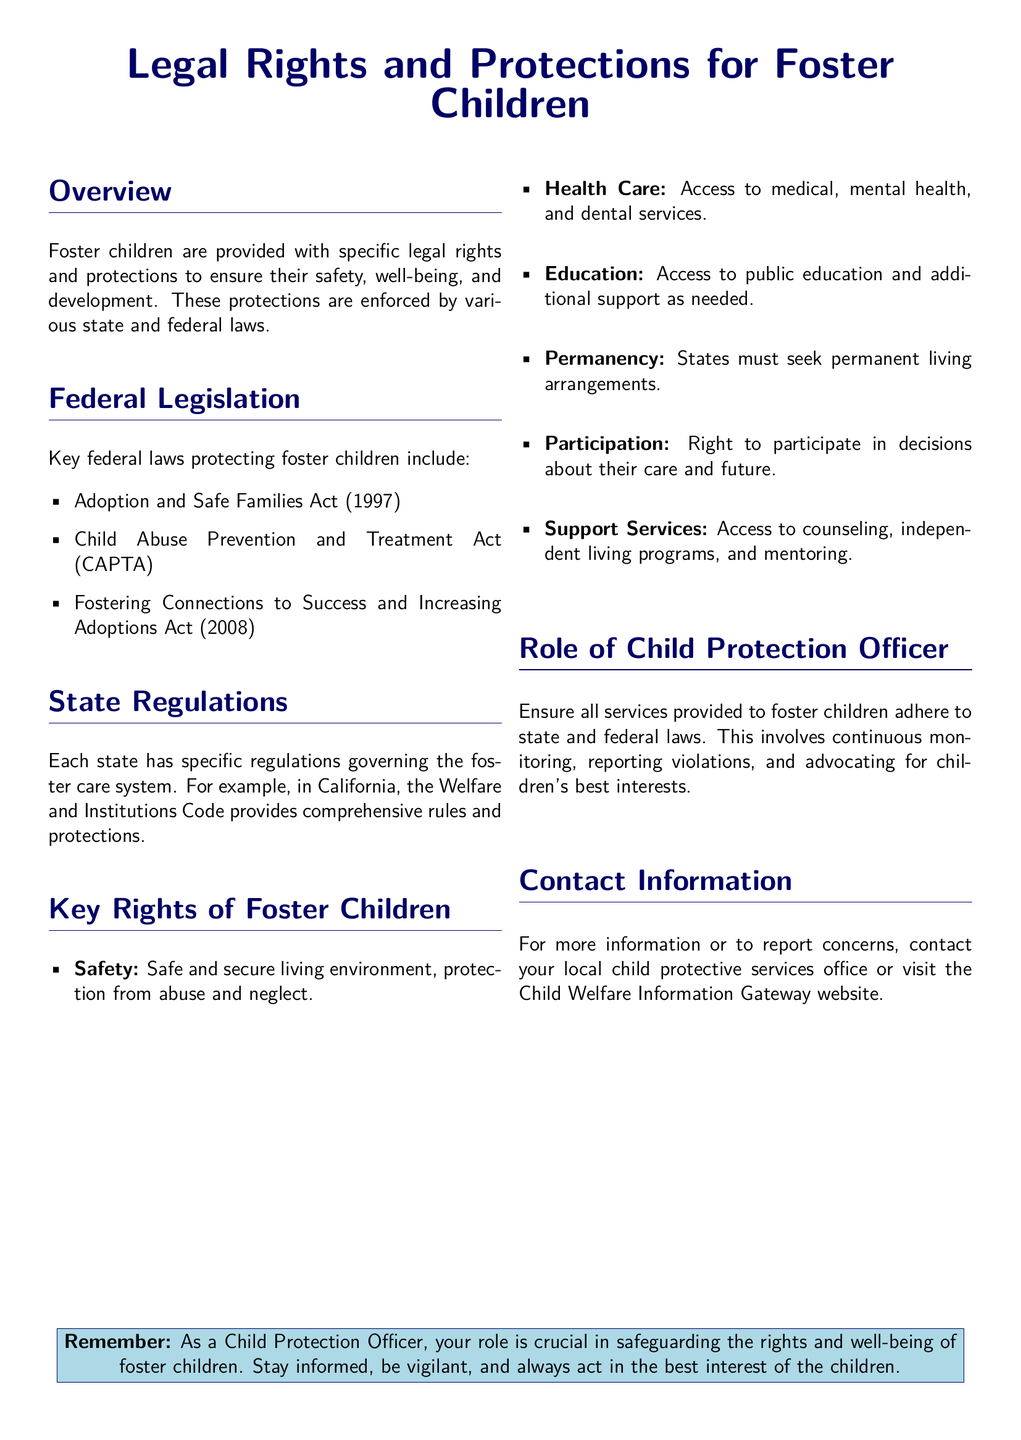What is the purpose of legal rights and protections for foster children? The purpose is to ensure their safety, well-being, and development.
Answer: Safety, well-being, and development What year was the Adoption and Safe Families Act enacted? The document states that the Adoption and Safe Families Act was enacted in 1997.
Answer: 1997 What type of environment must foster children have according to their rights? The document specifies that they must have a safe and secure living environment.
Answer: Safe and secure living environment Which federal act focuses on preventing child abuse? The specific act mentioned for preventing child abuse is the Child Abuse Prevention and Treatment Act (CAPTA).
Answer: Child Abuse Prevention and Treatment Act (CAPTA) What is one of the roles of a Child Protection Officer? The document lists continuous monitoring as one of the roles of a Child Protection Officer.
Answer: Continuous monitoring How many key rights of foster children are listed in the document? The document outlines six key rights of foster children.
Answer: Six What services are foster children entitled to access regarding their health? Foster children are entitled to access medical, mental health, and dental services.
Answer: Medical, mental health, and dental services Which state's regulations are mentioned as an example? The document mentions California's regulations as an example of state regulations.
Answer: California What is the contact method to report concerns according to the document? The document advises contacting local child protective services or visiting the Child Welfare Information Gateway website.
Answer: Local child protective services office or Child Welfare Information Gateway website 